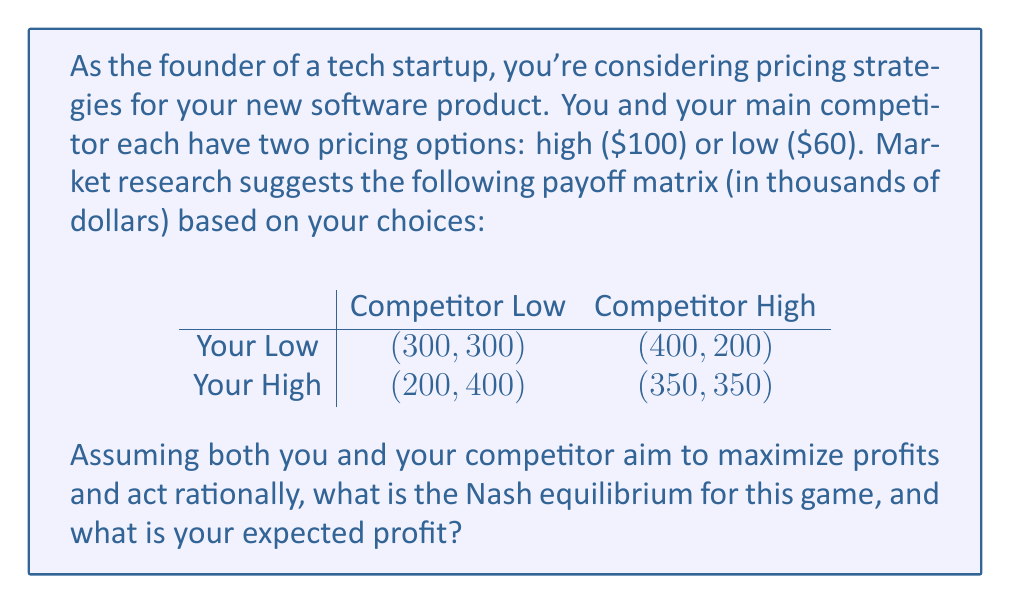Could you help me with this problem? To solve this problem, we need to apply game theory concepts, specifically the Nash equilibrium.

1) First, let's identify the best responses for each player:

   For you:
   - If competitor chooses Low: Your best response is Low (300 > 200)
   - If competitor chooses High: Your best response is Low (400 > 350)

   For the competitor:
   - If you choose Low: Competitor's best response is Low (300 > 200)
   - If you choose High: Competitor's best response is Low (400 > 350)

2) The Nash equilibrium occurs when both players are playing their best responses to each other's strategies. In this case, it's when both players choose Low pricing.

3) At this equilibrium point (Low, Low), neither player has an incentive to unilaterally change their strategy, as doing so would result in lower profits.

4) The payoff at this Nash equilibrium is (300, 300), meaning both you and your competitor would earn $300,000.

Therefore, the Nash equilibrium for this game is (Low, Low), and your expected profit is $300,000.
Answer: The Nash equilibrium is (Low, Low), with an expected profit of $300,000. 